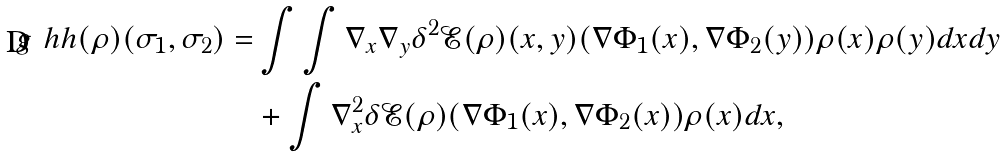<formula> <loc_0><loc_0><loc_500><loc_500>\ g ^ { \ } h h ( \rho ) ( \sigma _ { 1 } , \sigma _ { 2 } ) = & \int \int \nabla _ { x } \nabla _ { y } \delta ^ { 2 } \mathcal { E } ( \rho ) ( x , y ) ( \nabla \Phi _ { 1 } ( x ) , \nabla \Phi _ { 2 } ( y ) ) \rho ( x ) \rho ( y ) d x d y \\ & + \int \nabla _ { x } ^ { 2 } \delta \mathcal { E } ( \rho ) ( \nabla \Phi _ { 1 } ( x ) , \nabla \Phi _ { 2 } ( x ) ) \rho ( x ) d x ,</formula> 